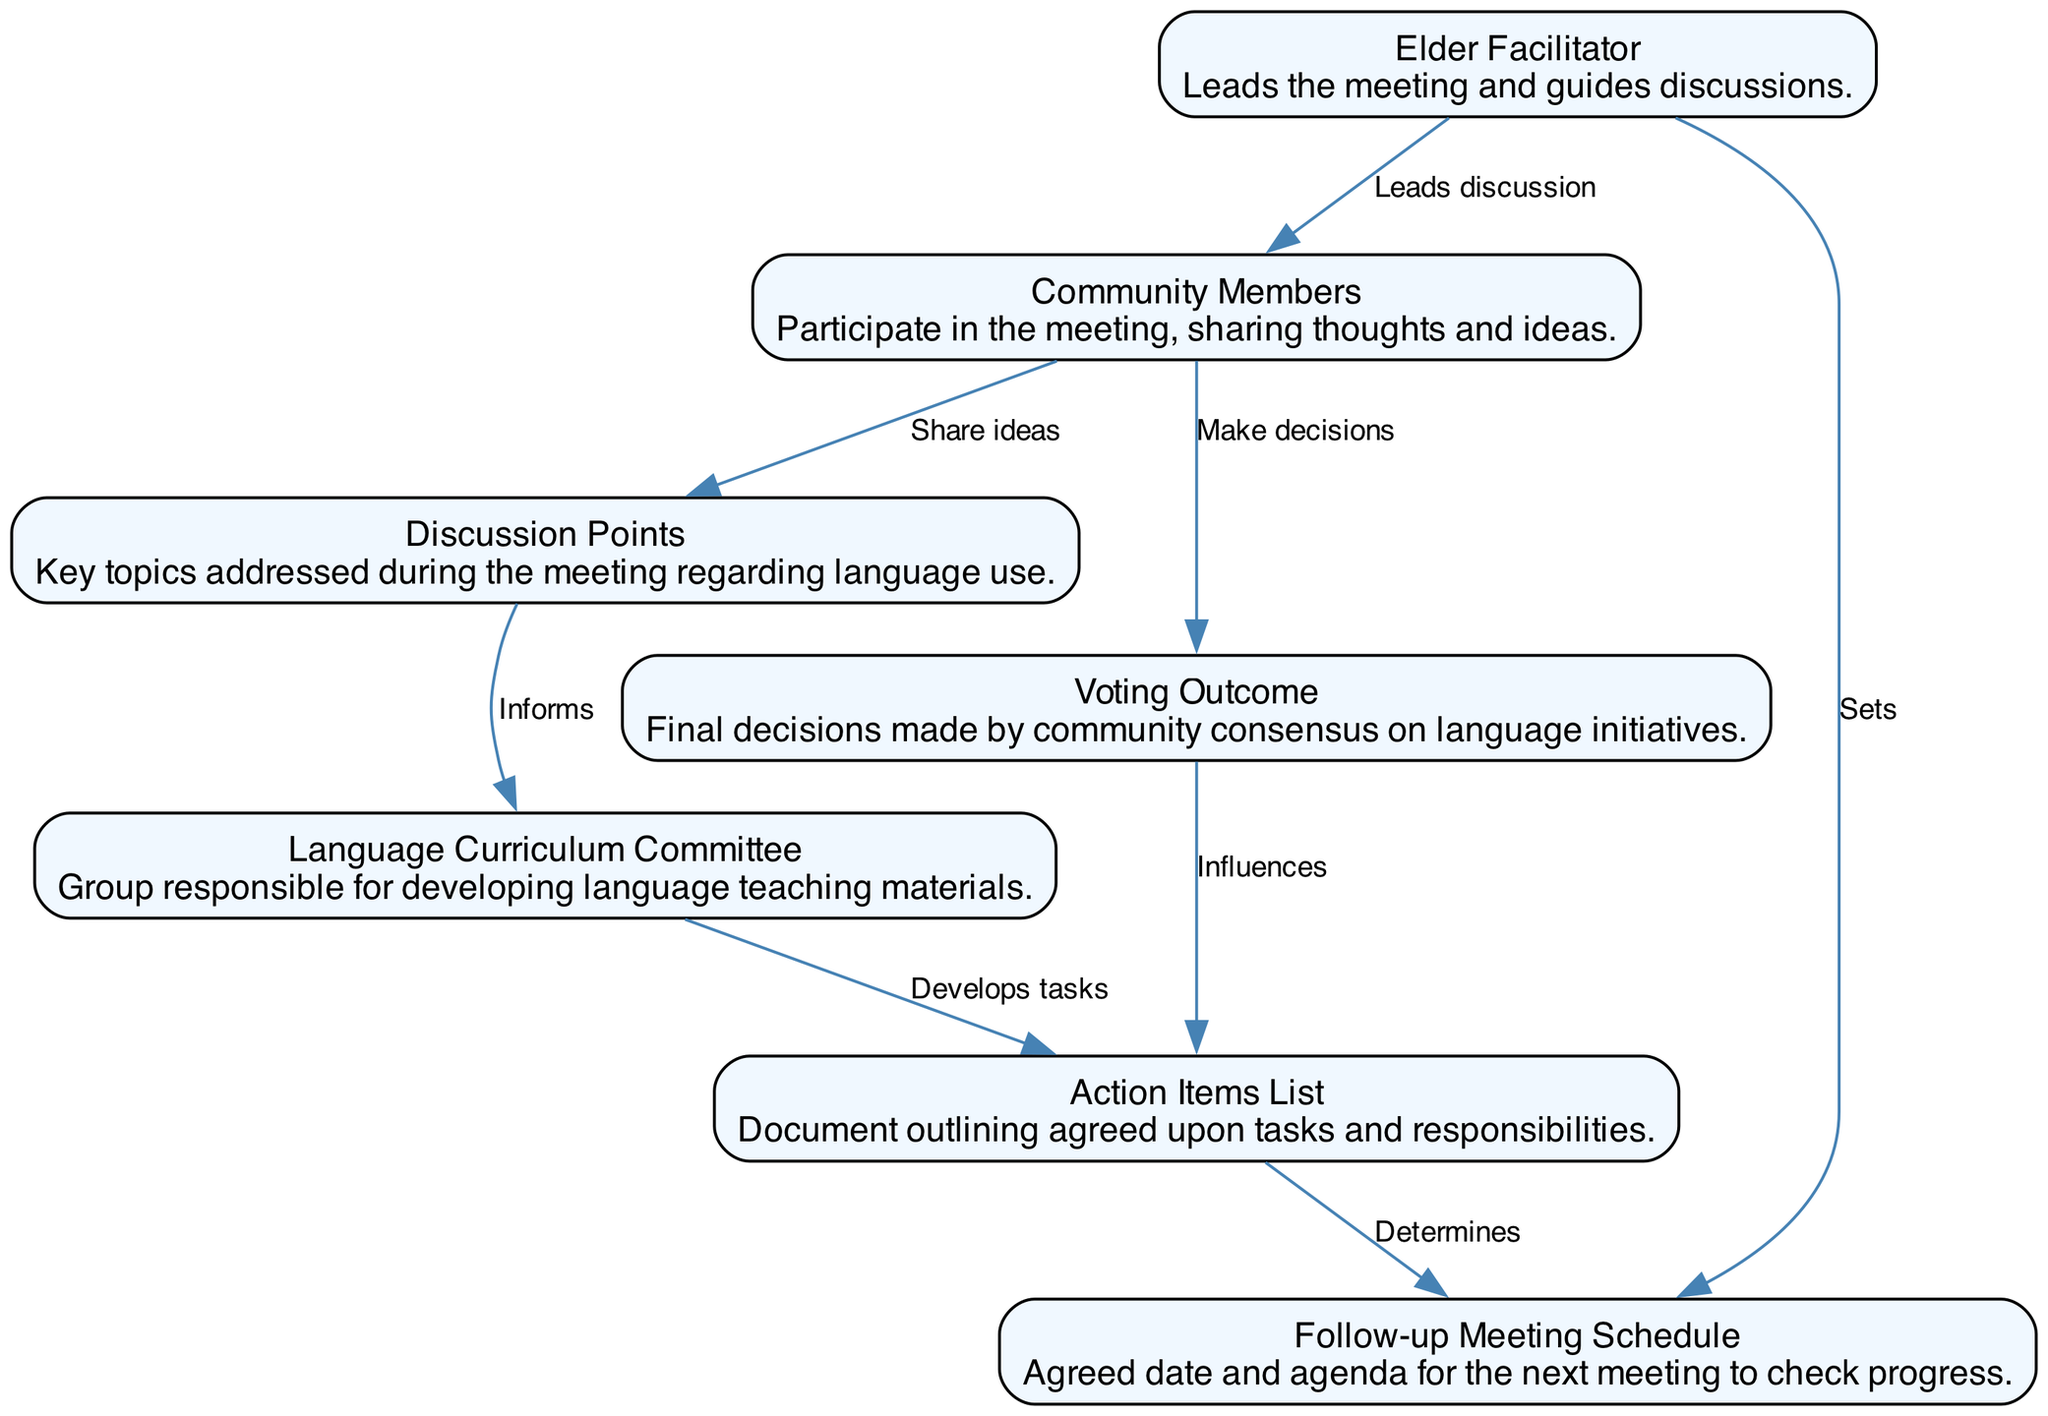What is the primary role of the Elder Facilitator? The Elder Facilitator leads the meeting and guides discussions. This is evident as they are the starting point in the flow of the diagram, influencing the Community Members and later connecting to the Follow-up Meeting Schedule.
Answer: Leads the meeting How many nodes are present in the diagram? By counting the elements listed, there are seven distinct nodes in the diagram: Elder Facilitator, Community Members, Language Curriculum Committee, Action Items List, Discussion Points, Voting Outcome, and Follow-up Meeting Schedule.
Answer: Seven What does the Community Members node share with the Discussion Points? The diagram clearly indicates that Community Members contribute ideas to the Discussion Points, establishing a direct influence in their interaction. This is shown by the edge leading from Community Members to Discussion Points, labeled 'Share ideas'.
Answer: Share ideas Which node determines the Follow-up Meeting Schedule? The edge from the Action Items List to the Follow-up Meeting Schedule shows that the Action Items List is responsible for determining the future meeting date and agenda. This is a crucial decision-making point in the outlined process.
Answer: Action Items List What influences the Action Items List, according to the diagram? The Voting Outcome directly influences the Action Items List, indicating that the decisions made by the community are subsequently reflected in the tasks and responsibilities listed. This relationship is represented by the edge labeled 'Influences'.
Answer: Voting Outcome What is the relationship between the Language Curriculum Committee and the Action Items List? The Language Curriculum Committee develops tasks that are added to the Action Items List, as shown by the edge connecting the two nodes with the label 'Develops tasks'. This relationship shows the progression from discussions to actionable items.
Answer: Develops tasks What is the outcome reported by the Voting Outcome node? The Voting Outcome node reflects the final decisions made by the community consensus on language initiatives, indicating that the discussions led to concrete choices impacting the language preservation efforts.
Answer: Final decisions What is the significance of the arrows in this sequence diagram? The arrows indicate the direction of influence or flow of information between nodes, showcasing how each element interacts with others in the sequence of conducting the language preservation meeting. This directional flow is crucial for understanding the process.
Answer: Direction of influence 